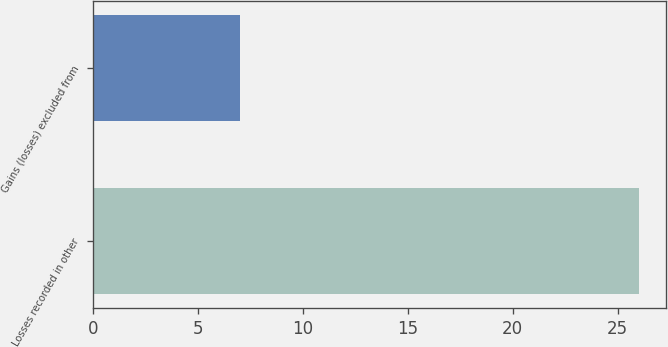Convert chart. <chart><loc_0><loc_0><loc_500><loc_500><bar_chart><fcel>Losses recorded in other<fcel>Gains (losses) excluded from<nl><fcel>26<fcel>7<nl></chart> 